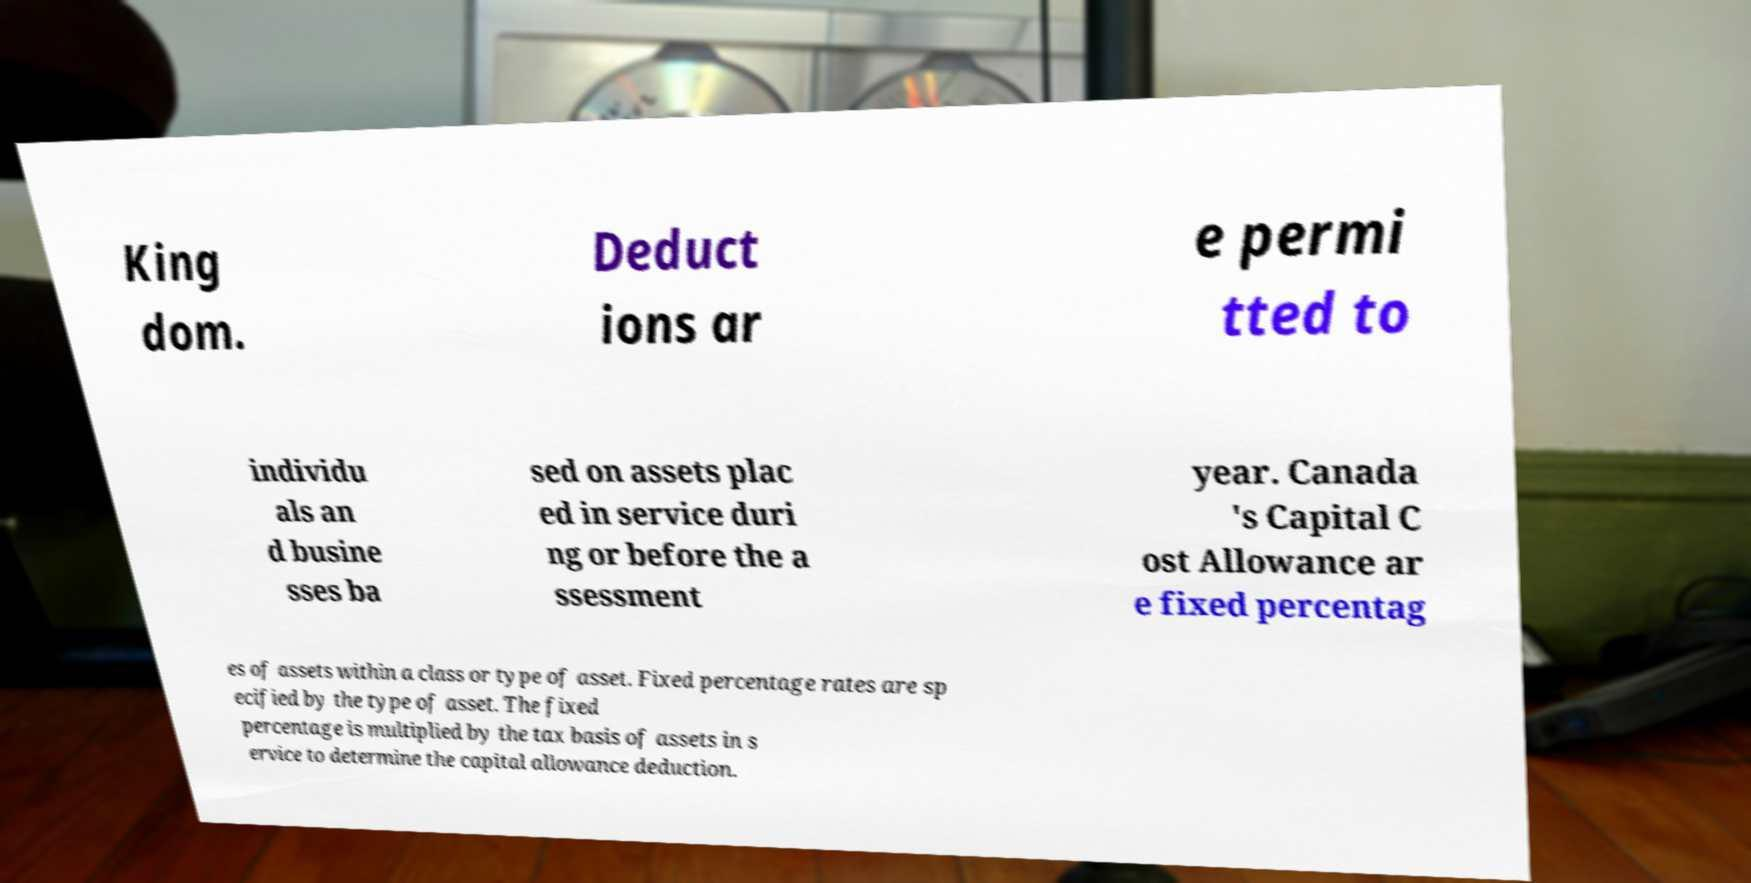Can you read and provide the text displayed in the image?This photo seems to have some interesting text. Can you extract and type it out for me? King dom. Deduct ions ar e permi tted to individu als an d busine sses ba sed on assets plac ed in service duri ng or before the a ssessment year. Canada 's Capital C ost Allowance ar e fixed percentag es of assets within a class or type of asset. Fixed percentage rates are sp ecified by the type of asset. The fixed percentage is multiplied by the tax basis of assets in s ervice to determine the capital allowance deduction. 